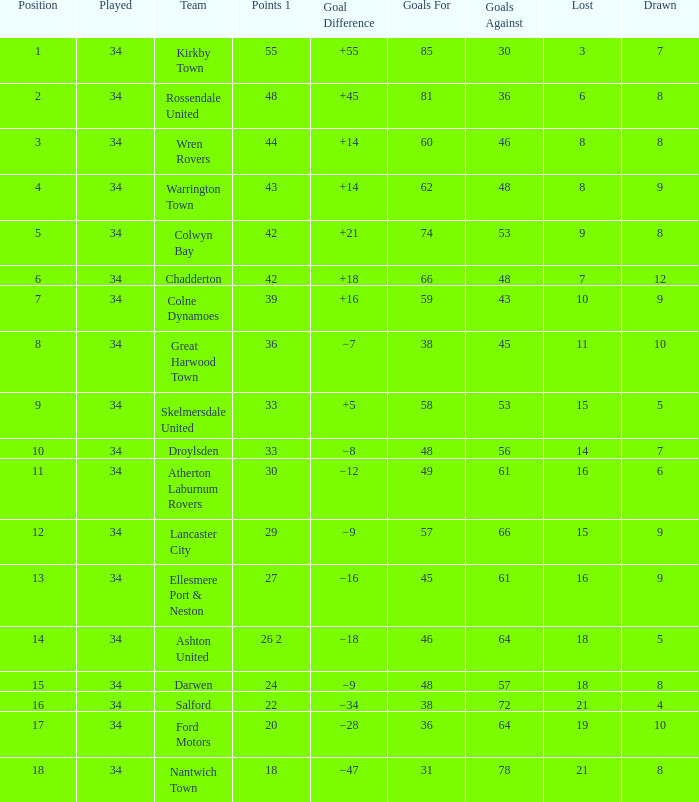What is the total number of goals for when the drawn is less than 7, less than 21 games have been lost, and there are 1 of 33 points? 1.0. 